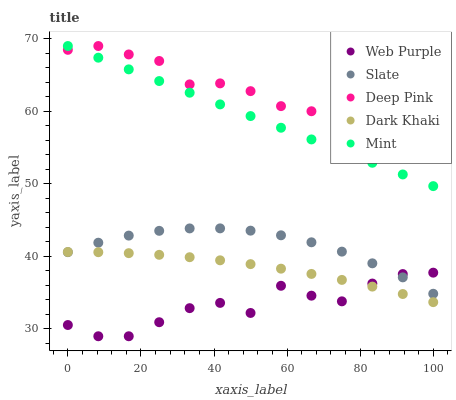Does Web Purple have the minimum area under the curve?
Answer yes or no. Yes. Does Deep Pink have the maximum area under the curve?
Answer yes or no. Yes. Does Deep Pink have the minimum area under the curve?
Answer yes or no. No. Does Web Purple have the maximum area under the curve?
Answer yes or no. No. Is Mint the smoothest?
Answer yes or no. Yes. Is Web Purple the roughest?
Answer yes or no. Yes. Is Deep Pink the smoothest?
Answer yes or no. No. Is Deep Pink the roughest?
Answer yes or no. No. Does Web Purple have the lowest value?
Answer yes or no. Yes. Does Deep Pink have the lowest value?
Answer yes or no. No. Does Mint have the highest value?
Answer yes or no. Yes. Does Web Purple have the highest value?
Answer yes or no. No. Is Slate less than Deep Pink?
Answer yes or no. Yes. Is Deep Pink greater than Web Purple?
Answer yes or no. Yes. Does Dark Khaki intersect Web Purple?
Answer yes or no. Yes. Is Dark Khaki less than Web Purple?
Answer yes or no. No. Is Dark Khaki greater than Web Purple?
Answer yes or no. No. Does Slate intersect Deep Pink?
Answer yes or no. No. 